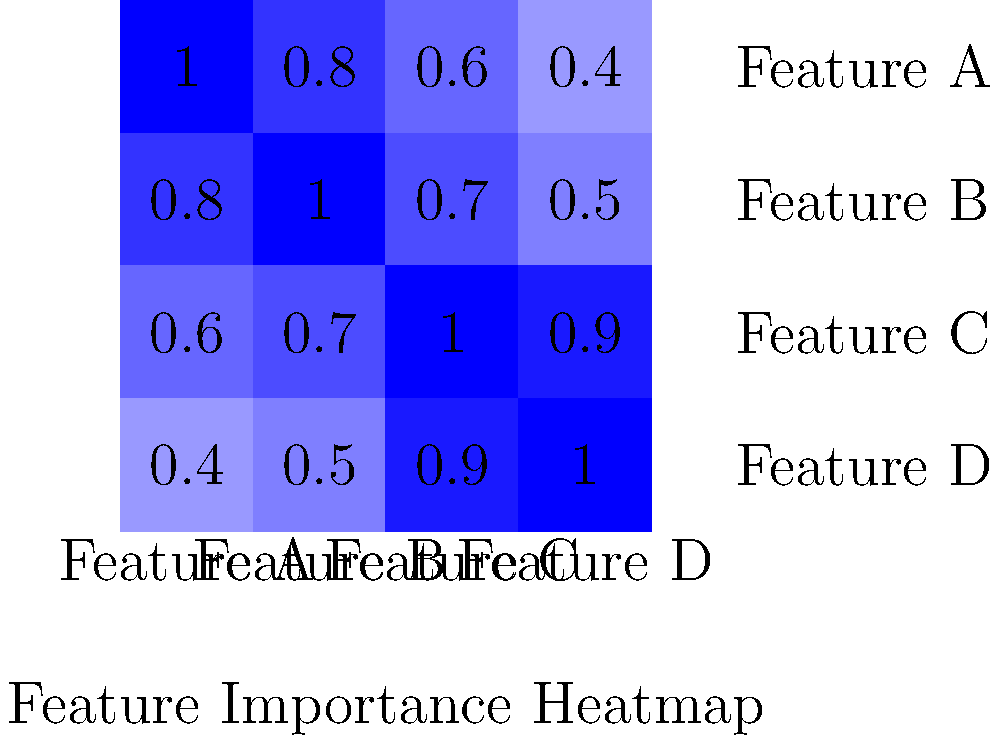As a product manager, you're reviewing a feature importance heatmap for a machine learning model. Based on the heatmap shown, which feature appears to have the strongest correlation with the target variable and would likely have the most significant impact on model performance if removed? To determine which feature has the strongest correlation with the target variable and would have the most significant impact on model performance if removed, we need to analyze the heatmap:

1. The heatmap shows the correlation between different features (A, B, C, and D).
2. The diagonal of the heatmap always shows a perfect correlation (1.0) as it represents a feature's correlation with itself.
3. We need to look for the feature that has the highest correlation values with other features, indicating its importance in the model.

Analyzing each feature:

1. Feature A: Has correlations of 0.8, 0.6, and 0.4 with other features.
2. Feature B: Has correlations of 0.8, 0.7, and 0.5 with other features.
3. Feature C: Has correlations of 0.6, 0.7, and 0.9 with other features.
4. Feature D: Has correlations of 0.4, 0.5, and 0.9 with other features.

Feature C has the highest overall correlations with other features (0.6, 0.7, and 0.9). This suggests that Feature C is the most important feature in the model and would likely have the most significant impact on model performance if removed.
Answer: Feature C 